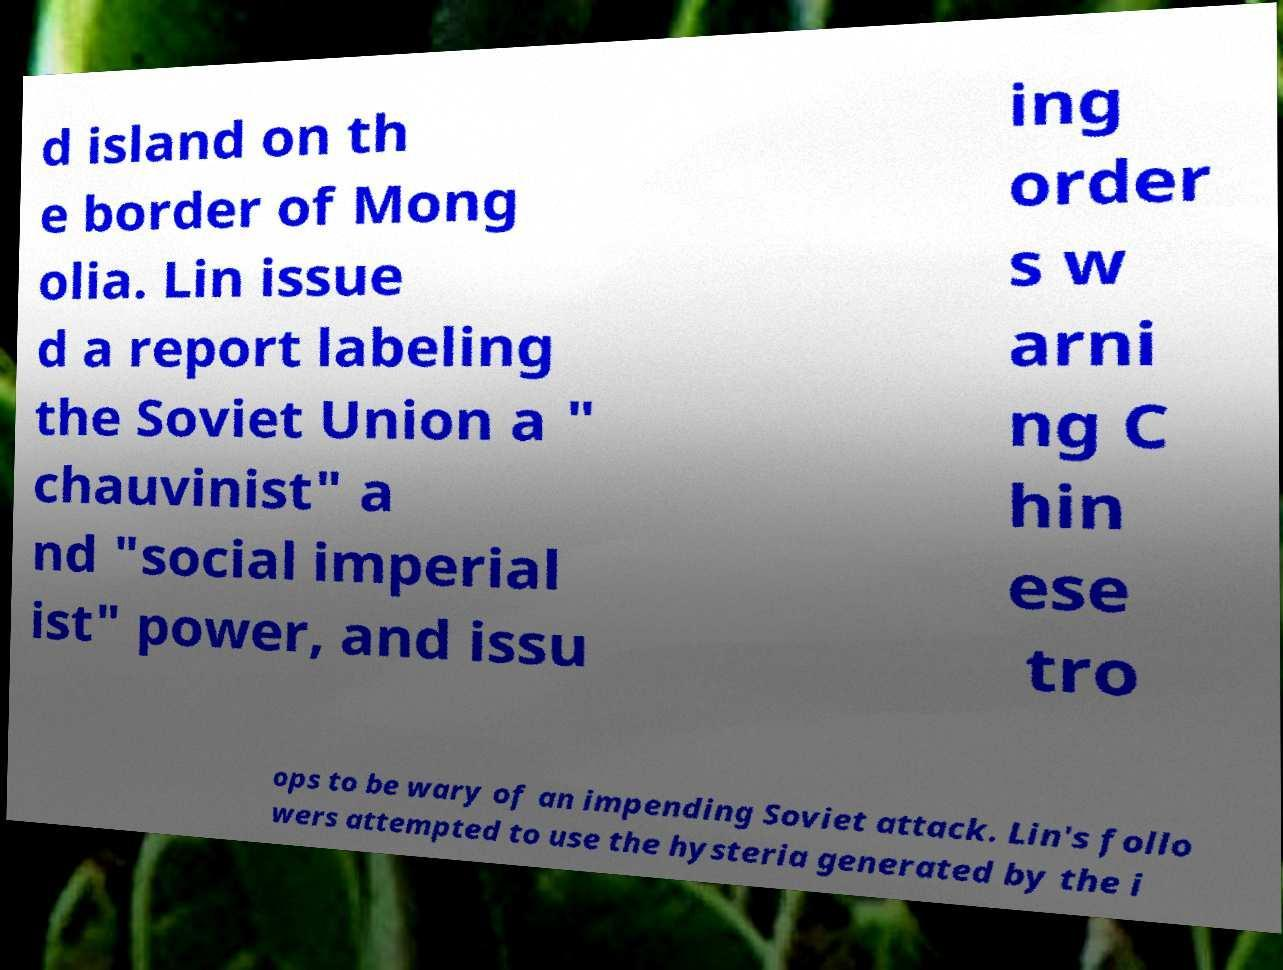What messages or text are displayed in this image? I need them in a readable, typed format. d island on th e border of Mong olia. Lin issue d a report labeling the Soviet Union a " chauvinist" a nd "social imperial ist" power, and issu ing order s w arni ng C hin ese tro ops to be wary of an impending Soviet attack. Lin's follo wers attempted to use the hysteria generated by the i 